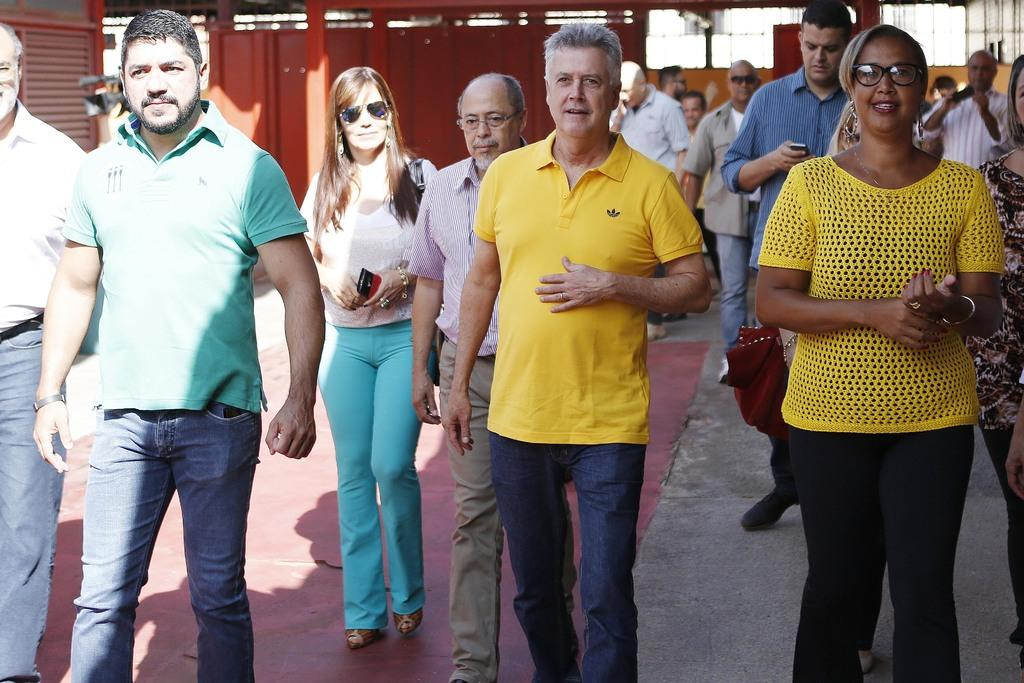Who or what is present in the image? There are people in the image. Where are the people located? The people are on a path. What is the color of the carpet visible in the image? There is a red color carpet in the image. What can be seen in the background of the image? There is fencing in the background of the image. What type of produce is being harvested by the ants in the image? There are no ants or produce present in the image. 